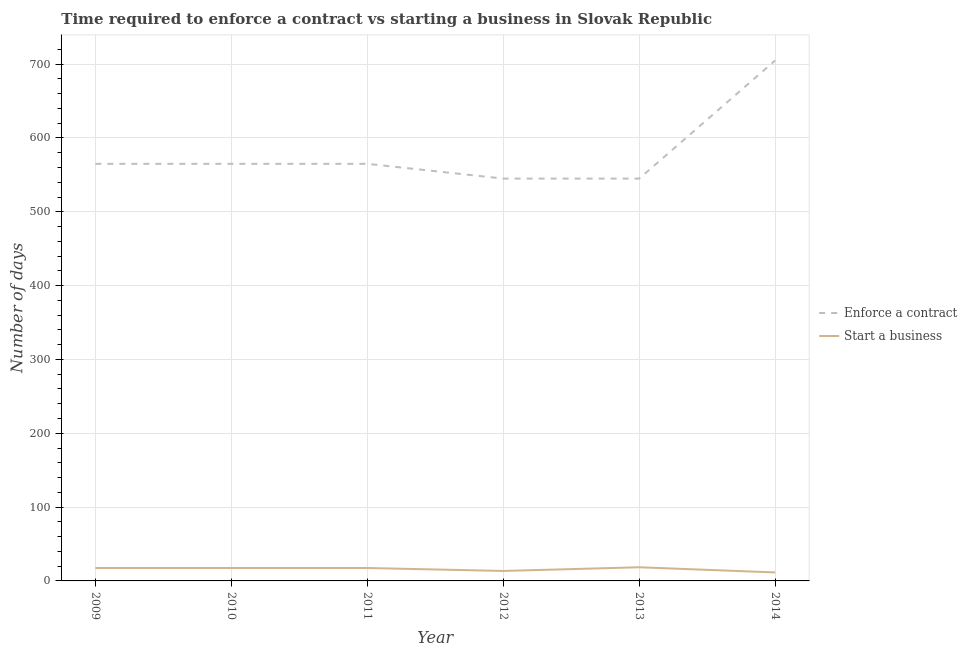How many different coloured lines are there?
Offer a terse response. 2. Does the line corresponding to number of days to enforece a contract intersect with the line corresponding to number of days to start a business?
Make the answer very short. No. Across all years, what is the minimum number of days to enforece a contract?
Keep it short and to the point. 545. In which year was the number of days to start a business maximum?
Your answer should be compact. 2013. What is the total number of days to enforece a contract in the graph?
Keep it short and to the point. 3490. What is the difference between the number of days to enforece a contract in 2010 and that in 2013?
Keep it short and to the point. 20. What is the difference between the number of days to start a business in 2011 and the number of days to enforece a contract in 2012?
Your answer should be very brief. -527.5. What is the average number of days to enforece a contract per year?
Your response must be concise. 581.67. In the year 2013, what is the difference between the number of days to start a business and number of days to enforece a contract?
Offer a very short reply. -526.5. In how many years, is the number of days to start a business greater than 180 days?
Your answer should be compact. 0. What is the ratio of the number of days to start a business in 2012 to that in 2014?
Ensure brevity in your answer.  1.17. What is the difference between the highest and the second highest number of days to enforece a contract?
Your answer should be compact. 140. What is the difference between the highest and the lowest number of days to enforece a contract?
Give a very brief answer. 160. Is the sum of the number of days to enforece a contract in 2011 and 2013 greater than the maximum number of days to start a business across all years?
Your answer should be very brief. Yes. Does the number of days to enforece a contract monotonically increase over the years?
Provide a succinct answer. No. How many lines are there?
Provide a succinct answer. 2. What is the difference between two consecutive major ticks on the Y-axis?
Your answer should be very brief. 100. Are the values on the major ticks of Y-axis written in scientific E-notation?
Your answer should be very brief. No. Does the graph contain grids?
Offer a terse response. Yes. Where does the legend appear in the graph?
Your answer should be compact. Center right. What is the title of the graph?
Ensure brevity in your answer.  Time required to enforce a contract vs starting a business in Slovak Republic. What is the label or title of the Y-axis?
Your answer should be compact. Number of days. What is the Number of days in Enforce a contract in 2009?
Your response must be concise. 565. What is the Number of days in Start a business in 2009?
Make the answer very short. 17.5. What is the Number of days of Enforce a contract in 2010?
Your answer should be very brief. 565. What is the Number of days of Start a business in 2010?
Provide a short and direct response. 17.5. What is the Number of days in Enforce a contract in 2011?
Provide a succinct answer. 565. What is the Number of days of Enforce a contract in 2012?
Your response must be concise. 545. What is the Number of days of Enforce a contract in 2013?
Offer a very short reply. 545. What is the Number of days in Start a business in 2013?
Ensure brevity in your answer.  18.5. What is the Number of days in Enforce a contract in 2014?
Your answer should be very brief. 705. What is the Number of days of Start a business in 2014?
Your response must be concise. 11.5. Across all years, what is the maximum Number of days in Enforce a contract?
Keep it short and to the point. 705. Across all years, what is the minimum Number of days of Enforce a contract?
Your answer should be very brief. 545. What is the total Number of days of Enforce a contract in the graph?
Provide a short and direct response. 3490. What is the total Number of days in Start a business in the graph?
Provide a succinct answer. 96. What is the difference between the Number of days of Enforce a contract in 2009 and that in 2010?
Keep it short and to the point. 0. What is the difference between the Number of days in Start a business in 2009 and that in 2010?
Offer a terse response. 0. What is the difference between the Number of days in Start a business in 2009 and that in 2011?
Offer a terse response. 0. What is the difference between the Number of days in Enforce a contract in 2009 and that in 2012?
Give a very brief answer. 20. What is the difference between the Number of days of Enforce a contract in 2009 and that in 2014?
Provide a succinct answer. -140. What is the difference between the Number of days in Start a business in 2009 and that in 2014?
Keep it short and to the point. 6. What is the difference between the Number of days in Enforce a contract in 2010 and that in 2011?
Provide a short and direct response. 0. What is the difference between the Number of days in Start a business in 2010 and that in 2012?
Your answer should be compact. 4. What is the difference between the Number of days in Enforce a contract in 2010 and that in 2013?
Provide a short and direct response. 20. What is the difference between the Number of days of Start a business in 2010 and that in 2013?
Make the answer very short. -1. What is the difference between the Number of days of Enforce a contract in 2010 and that in 2014?
Your response must be concise. -140. What is the difference between the Number of days in Start a business in 2010 and that in 2014?
Provide a succinct answer. 6. What is the difference between the Number of days in Start a business in 2011 and that in 2012?
Your response must be concise. 4. What is the difference between the Number of days of Enforce a contract in 2011 and that in 2013?
Keep it short and to the point. 20. What is the difference between the Number of days in Start a business in 2011 and that in 2013?
Your answer should be very brief. -1. What is the difference between the Number of days of Enforce a contract in 2011 and that in 2014?
Offer a terse response. -140. What is the difference between the Number of days of Start a business in 2011 and that in 2014?
Make the answer very short. 6. What is the difference between the Number of days of Enforce a contract in 2012 and that in 2014?
Your answer should be compact. -160. What is the difference between the Number of days in Enforce a contract in 2013 and that in 2014?
Provide a succinct answer. -160. What is the difference between the Number of days of Start a business in 2013 and that in 2014?
Your answer should be compact. 7. What is the difference between the Number of days in Enforce a contract in 2009 and the Number of days in Start a business in 2010?
Ensure brevity in your answer.  547.5. What is the difference between the Number of days of Enforce a contract in 2009 and the Number of days of Start a business in 2011?
Offer a terse response. 547.5. What is the difference between the Number of days of Enforce a contract in 2009 and the Number of days of Start a business in 2012?
Offer a terse response. 551.5. What is the difference between the Number of days of Enforce a contract in 2009 and the Number of days of Start a business in 2013?
Your answer should be compact. 546.5. What is the difference between the Number of days in Enforce a contract in 2009 and the Number of days in Start a business in 2014?
Your answer should be compact. 553.5. What is the difference between the Number of days in Enforce a contract in 2010 and the Number of days in Start a business in 2011?
Offer a very short reply. 547.5. What is the difference between the Number of days in Enforce a contract in 2010 and the Number of days in Start a business in 2012?
Your answer should be very brief. 551.5. What is the difference between the Number of days of Enforce a contract in 2010 and the Number of days of Start a business in 2013?
Your response must be concise. 546.5. What is the difference between the Number of days in Enforce a contract in 2010 and the Number of days in Start a business in 2014?
Your response must be concise. 553.5. What is the difference between the Number of days in Enforce a contract in 2011 and the Number of days in Start a business in 2012?
Your answer should be very brief. 551.5. What is the difference between the Number of days in Enforce a contract in 2011 and the Number of days in Start a business in 2013?
Offer a very short reply. 546.5. What is the difference between the Number of days in Enforce a contract in 2011 and the Number of days in Start a business in 2014?
Provide a short and direct response. 553.5. What is the difference between the Number of days of Enforce a contract in 2012 and the Number of days of Start a business in 2013?
Make the answer very short. 526.5. What is the difference between the Number of days of Enforce a contract in 2012 and the Number of days of Start a business in 2014?
Provide a succinct answer. 533.5. What is the difference between the Number of days in Enforce a contract in 2013 and the Number of days in Start a business in 2014?
Your answer should be very brief. 533.5. What is the average Number of days of Enforce a contract per year?
Your answer should be very brief. 581.67. What is the average Number of days of Start a business per year?
Your answer should be very brief. 16. In the year 2009, what is the difference between the Number of days in Enforce a contract and Number of days in Start a business?
Provide a short and direct response. 547.5. In the year 2010, what is the difference between the Number of days of Enforce a contract and Number of days of Start a business?
Your response must be concise. 547.5. In the year 2011, what is the difference between the Number of days of Enforce a contract and Number of days of Start a business?
Your response must be concise. 547.5. In the year 2012, what is the difference between the Number of days in Enforce a contract and Number of days in Start a business?
Your answer should be very brief. 531.5. In the year 2013, what is the difference between the Number of days in Enforce a contract and Number of days in Start a business?
Offer a very short reply. 526.5. In the year 2014, what is the difference between the Number of days of Enforce a contract and Number of days of Start a business?
Your answer should be very brief. 693.5. What is the ratio of the Number of days of Enforce a contract in 2009 to that in 2012?
Give a very brief answer. 1.04. What is the ratio of the Number of days of Start a business in 2009 to that in 2012?
Provide a short and direct response. 1.3. What is the ratio of the Number of days of Enforce a contract in 2009 to that in 2013?
Ensure brevity in your answer.  1.04. What is the ratio of the Number of days of Start a business in 2009 to that in 2013?
Offer a terse response. 0.95. What is the ratio of the Number of days in Enforce a contract in 2009 to that in 2014?
Keep it short and to the point. 0.8. What is the ratio of the Number of days of Start a business in 2009 to that in 2014?
Your answer should be very brief. 1.52. What is the ratio of the Number of days in Start a business in 2010 to that in 2011?
Make the answer very short. 1. What is the ratio of the Number of days in Enforce a contract in 2010 to that in 2012?
Ensure brevity in your answer.  1.04. What is the ratio of the Number of days of Start a business in 2010 to that in 2012?
Offer a very short reply. 1.3. What is the ratio of the Number of days of Enforce a contract in 2010 to that in 2013?
Give a very brief answer. 1.04. What is the ratio of the Number of days in Start a business in 2010 to that in 2013?
Offer a very short reply. 0.95. What is the ratio of the Number of days in Enforce a contract in 2010 to that in 2014?
Provide a short and direct response. 0.8. What is the ratio of the Number of days in Start a business in 2010 to that in 2014?
Your response must be concise. 1.52. What is the ratio of the Number of days of Enforce a contract in 2011 to that in 2012?
Your response must be concise. 1.04. What is the ratio of the Number of days of Start a business in 2011 to that in 2012?
Provide a succinct answer. 1.3. What is the ratio of the Number of days in Enforce a contract in 2011 to that in 2013?
Offer a very short reply. 1.04. What is the ratio of the Number of days in Start a business in 2011 to that in 2013?
Provide a succinct answer. 0.95. What is the ratio of the Number of days in Enforce a contract in 2011 to that in 2014?
Provide a short and direct response. 0.8. What is the ratio of the Number of days of Start a business in 2011 to that in 2014?
Make the answer very short. 1.52. What is the ratio of the Number of days in Start a business in 2012 to that in 2013?
Your answer should be compact. 0.73. What is the ratio of the Number of days of Enforce a contract in 2012 to that in 2014?
Make the answer very short. 0.77. What is the ratio of the Number of days of Start a business in 2012 to that in 2014?
Give a very brief answer. 1.17. What is the ratio of the Number of days in Enforce a contract in 2013 to that in 2014?
Provide a short and direct response. 0.77. What is the ratio of the Number of days of Start a business in 2013 to that in 2014?
Give a very brief answer. 1.61. What is the difference between the highest and the second highest Number of days of Enforce a contract?
Your response must be concise. 140. What is the difference between the highest and the lowest Number of days in Enforce a contract?
Your answer should be compact. 160. What is the difference between the highest and the lowest Number of days in Start a business?
Give a very brief answer. 7. 